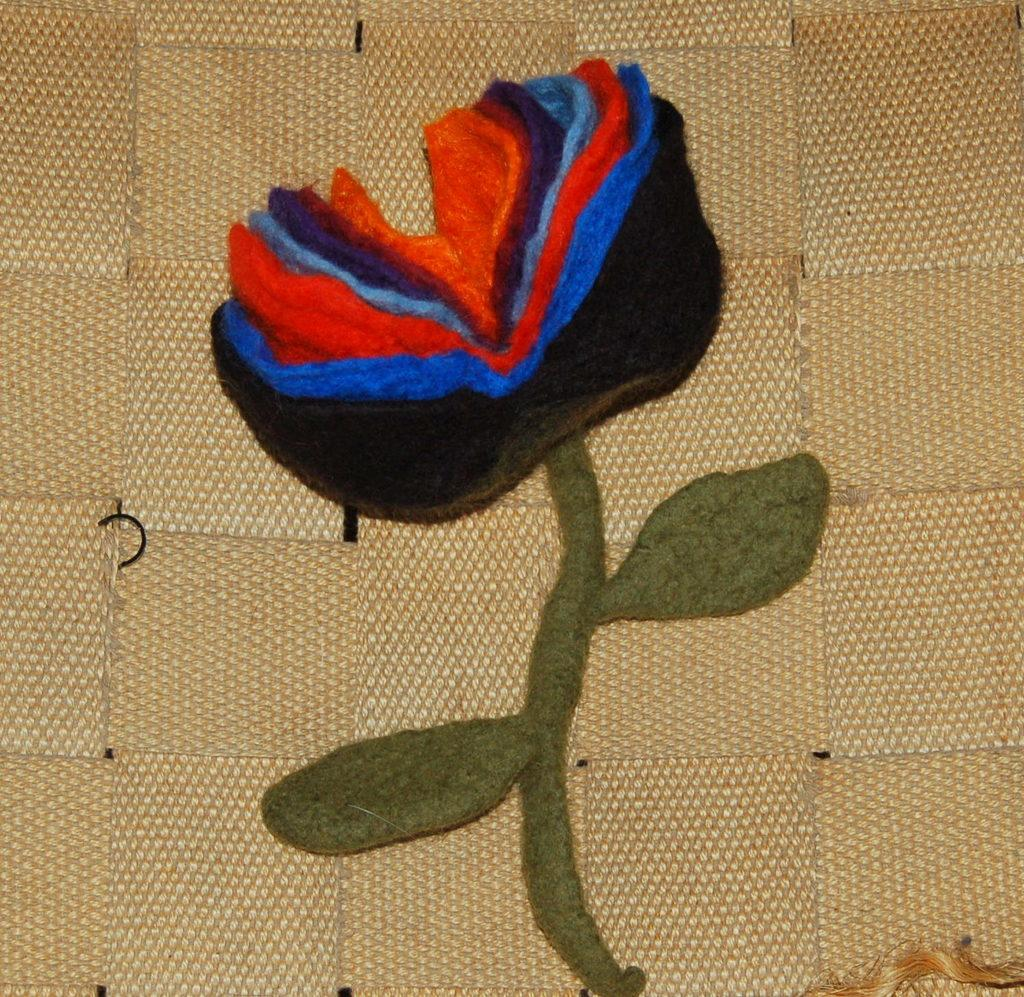What is depicted on the fabric in the image? There is a flower stitched on the fabric in the image. What is the color of the fabric? The fabric is of brown color. What type of glue is used to attach the lumber to the fabric in the image? There is no lumber or glue present in the image; it only features a flower stitched on a brown fabric. 